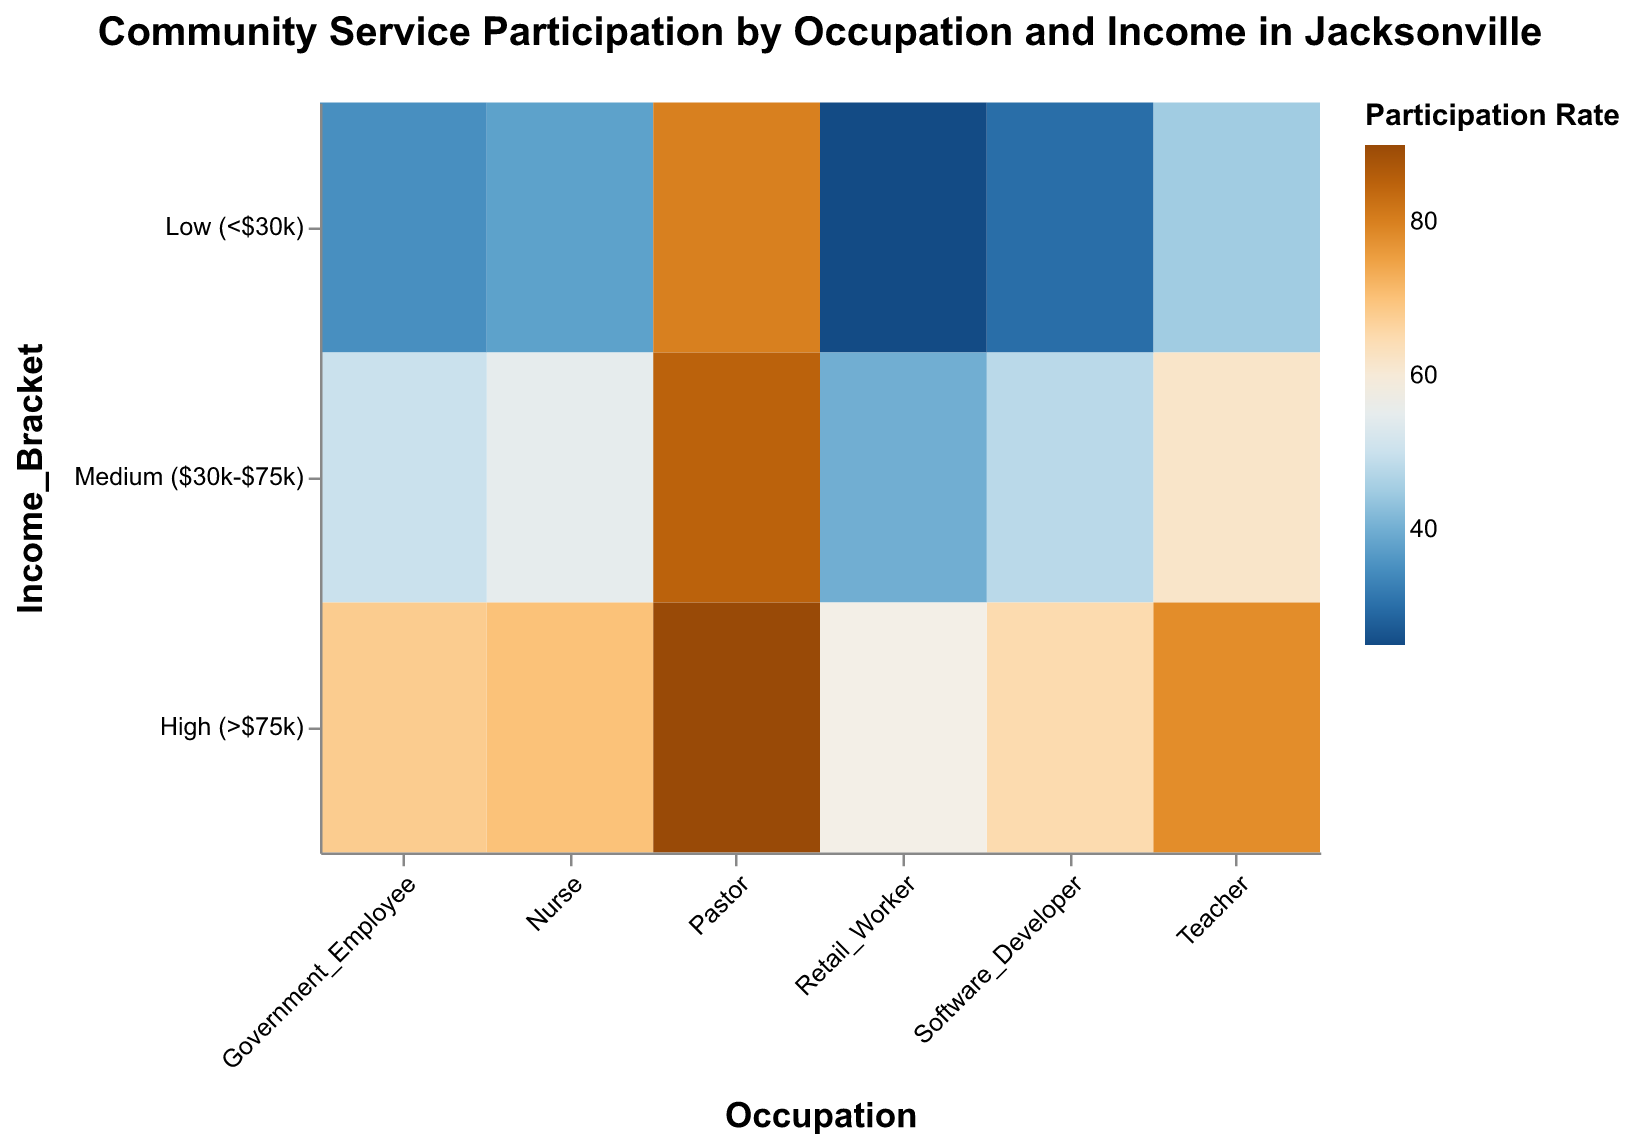What's the title of the figure? The title of a plot is usually located at the top and is visually distinct. From the code detail provided, the title is "Community Service Participation by Occupation and Income in Jacksonville".
Answer: Community Service Participation by Occupation and Income in Jacksonville Which occupation has the highest participation rate in the low-income bracket? Look for the "Low (<$30k)" section and identify the occupation with the highest value. In this case, "Pastor" has the highest participation rate at 80%.
Answer: Pastor What is the participation rate for Nurses in the high-income bracket? Locate the "Nurse" row and then find the intersection with the "High (>$75k)" column. The value present there is 70%.
Answer: 70 Which income bracket shows the highest participation rate among Retail Workers? For the "Retail_Worker" row, compare the values across the three income brackets. The highest participation rate is in the "High (>$75k)" bracket at 58%.
Answer: High (>$75k) Between Teachers and Software Developers, who has a higher participation rate in the medium-income bracket? Locate both "Teacher" and "Software_Developer" rows in the "Medium ($30k-$75k)" column, then compare their values: Teacher (62) vs. Software_Developer (48).
Answer: Teacher How does the participation rate of Government Employees in the low-income bracket compare to that of Nurses in the same bracket? For both "Government_Employee" and "Nurse" rows in the "Low (<$30k)" column, compare the values: Government_Employee (35) vs. Nurse (38).
Answer: Nurse has a higher rate What is the average participation rate of Software Developers across all income brackets? Sum the participation rates of Software Developers in all income brackets and divide by three: (30 + 48 + 65) / 3 = 47.67.
Answer: 47.67 Which occupation has the most variation in participation rates across different income brackets? Calculate the range of participation rates for each occupation and identify the highest difference. Pastor's rates vary from 80 to 90, while others have broader ranges. "Retail_Worker" has the largest variation from 25 to 58, a difference of 33.
Answer: Retail_Worker How does the participation rate of Pastors in the high-income bracket compare with Teachers in the same bracket? Compare the values of "Pastor" and "Teacher" in the "High (>$75k)" column: Pastor (90) vs. Teacher (78).
Answer: Pastor has a higher rate What is the participation rate difference between the highest and lowest income brackets for Teachers? Calculate the difference between participation rates of Teachers in high and low brackets: 78 - 45 = 33.
Answer: 33 